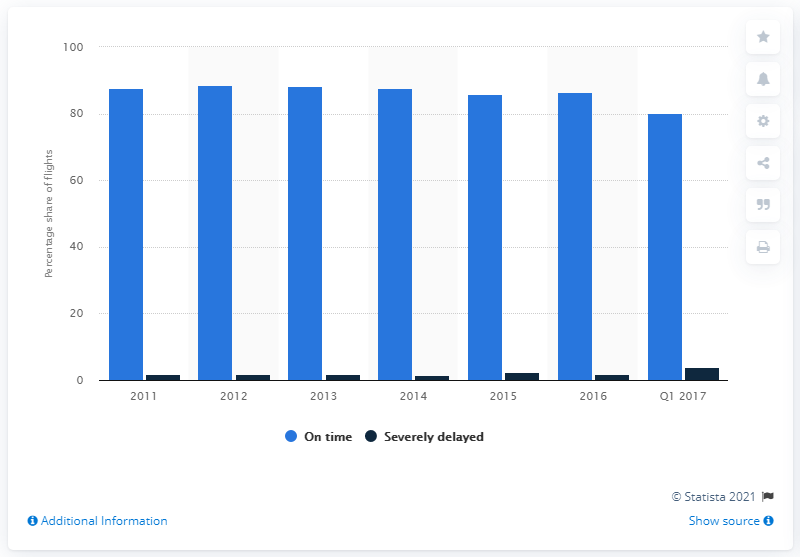List a handful of essential elements in this visual. In January, February, and March of 2017, approximately 80.2% of KLM flights arrived on time. 